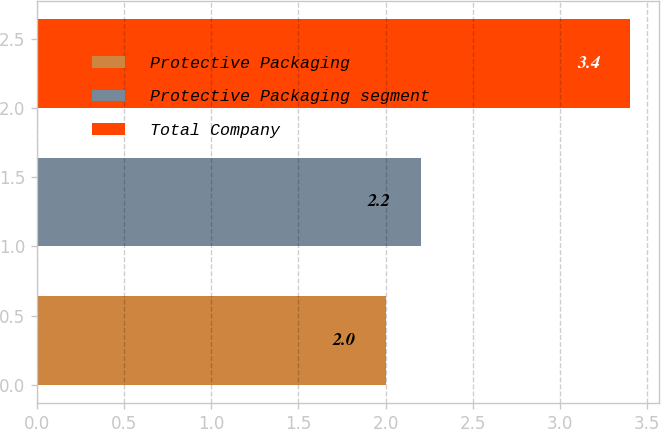Convert chart. <chart><loc_0><loc_0><loc_500><loc_500><bar_chart><fcel>Protective Packaging<fcel>Protective Packaging segment<fcel>Total Company<nl><fcel>2<fcel>2.2<fcel>3.4<nl></chart> 